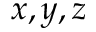Convert formula to latex. <formula><loc_0><loc_0><loc_500><loc_500>x , y , z</formula> 